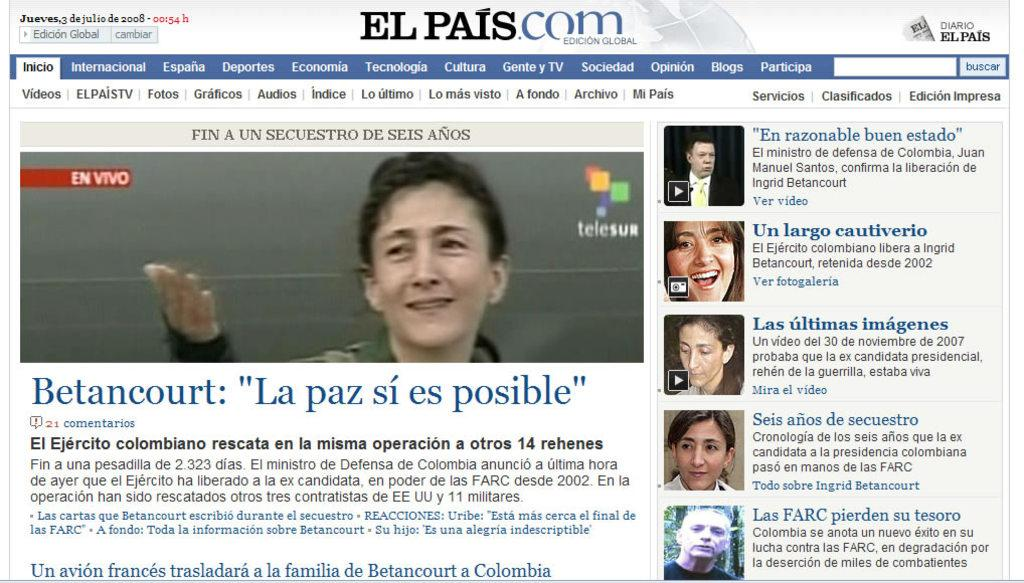What can be seen in the image? There are pictures of persons in the image. What else is present in the image besides the pictures of persons? There is writing on the image. What street is visible in the image? There is no street visible in the image; it only contains pictures of persons and writing. 